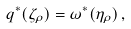Convert formula to latex. <formula><loc_0><loc_0><loc_500><loc_500>q ^ { * } ( \zeta _ { \rho } ) = { \omega } ^ { * } ( \eta _ { \rho } ) \, ,</formula> 